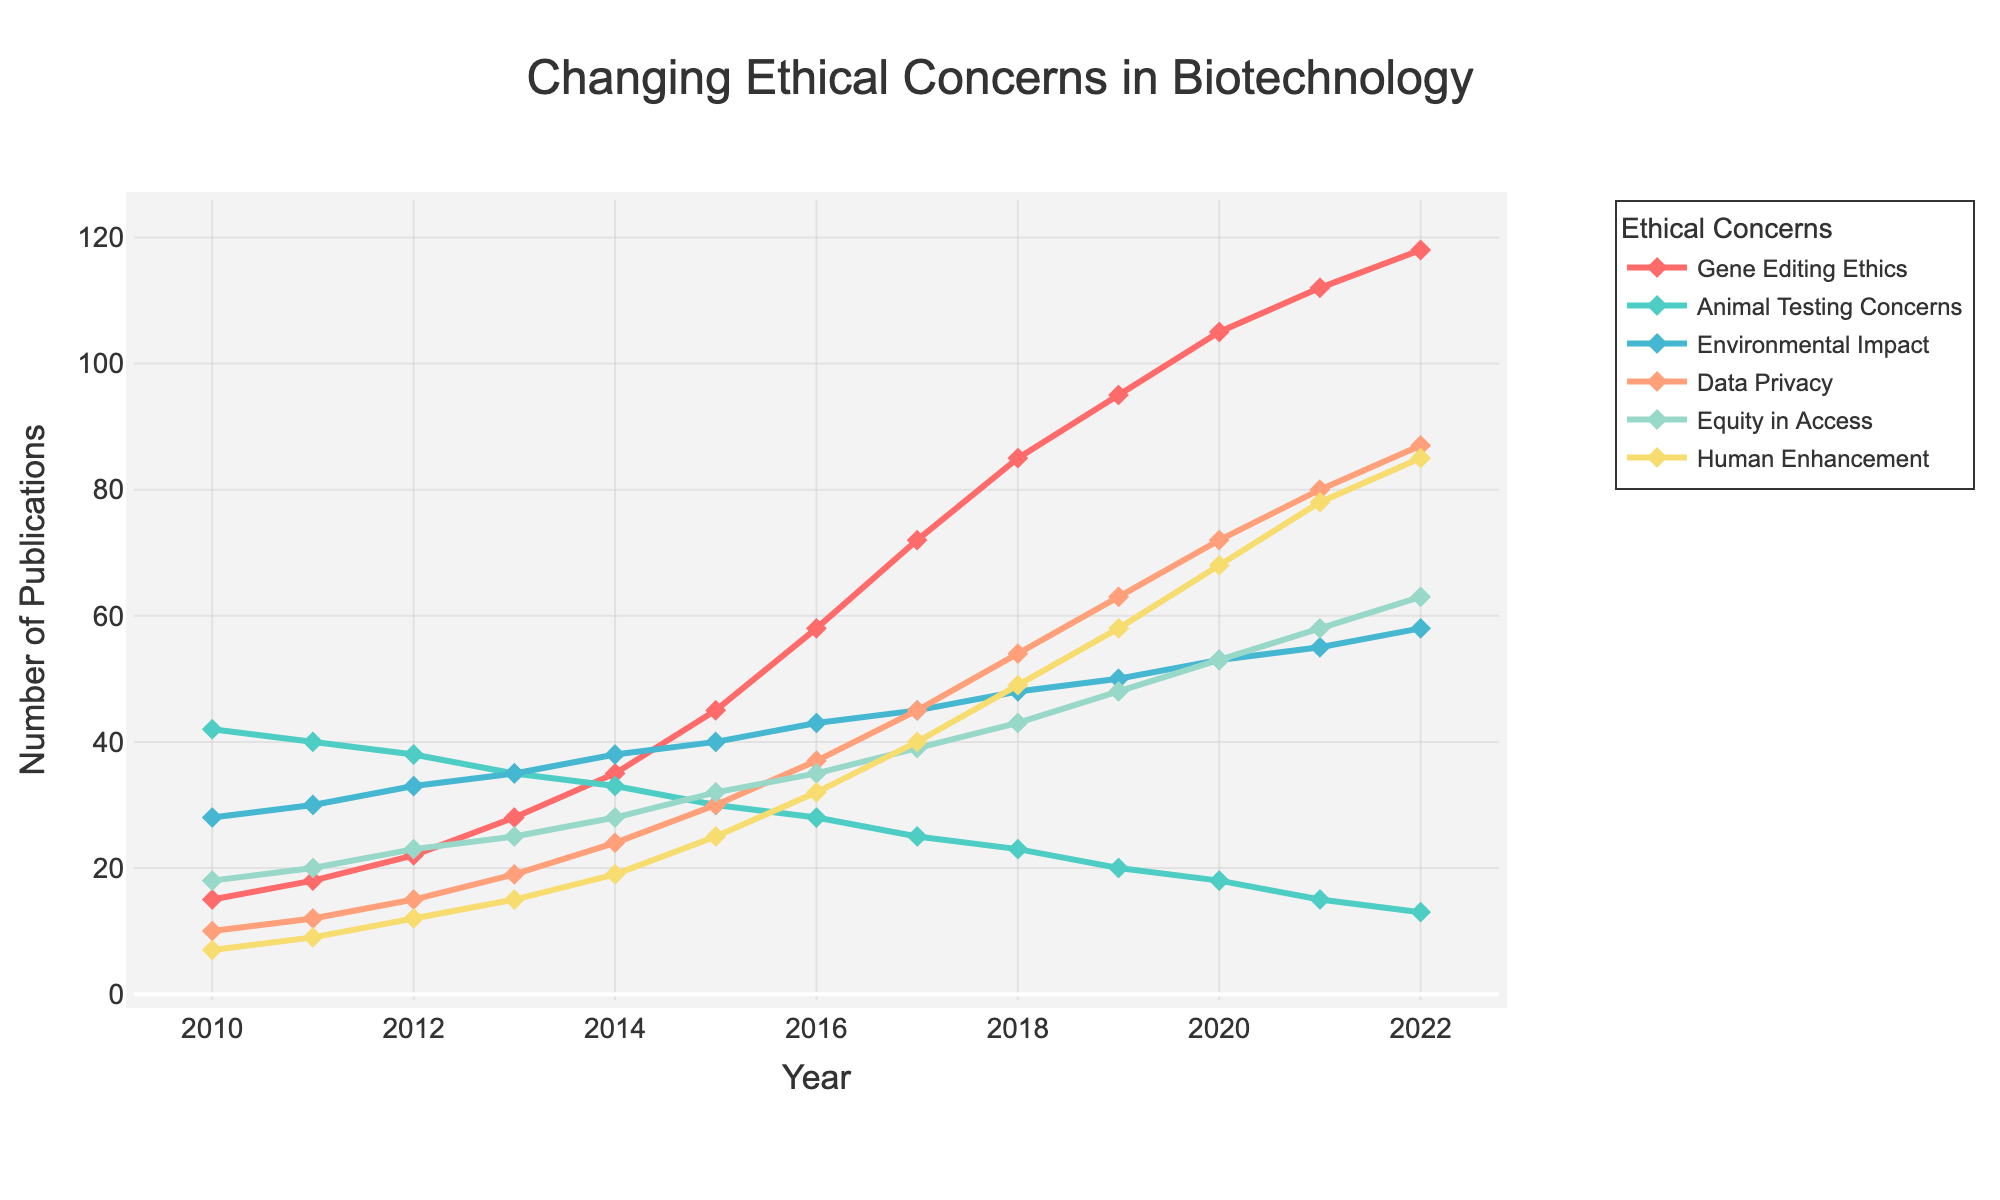Which ethical concern had the highest number of publications in 2022? To determine which ethical concern had the highest number of publications in 2022, look for the peak value in the data for the year 2022. "Gene Editing Ethics" has the highest value at 118 publications.
Answer: Gene Editing Ethics How has the trend for "Animal Testing Concerns" changed from 2010 to 2022? To understand the trend, look at the line representing "Animal Testing Concerns" and observe its direction from 2010 to 2022. The line shows a consistent decline in publications over this period.
Answer: Declined Which ethical concern saw the sharpest increase in publications between 2010 and 2022? Calculate the difference in publications for each concern between 2010 and 2022. The sharpest increase is for "Gene Editing Ethics," which increased from 15 to 118 publications, a difference of 103.
Answer: Gene Editing Ethics What is the difference between the number of publications on "Data Privacy" and "Environmental Impact" in 2020? Subtract the number of publications on "Environmental Impact" from the number on "Data Privacy" for 2020: 72 - 53 = 19.
Answer: 19 Which ethical concern switched from having fewer publications than "Equity in Access" in 2010 to having more publications in 2022? Compare the publications for "Equity in Access" and other concerns for 2010 and 2022. "Gene Editing Ethics" had fewer publications in 2010 (15 < 18) and more in 2022 (118 > 63).
Answer: Gene Editing Ethics What is the overall trend for the "Human Enhancement" publications from 2010 to 2022? Observe the line for "Human Enhancement" from 2010 to 2022. The line shows a continual upward trend, indicating an increase in publications.
Answer: Increased In which year did "Data Privacy" surpass "Animal Testing Concerns" in the number of publications? Trace the lines for "Data Privacy" and "Animal Testing Concerns" and find the year "Data Privacy" (in green) surpasses "Animal Testing Concerns" (in light blue). This occurs in 2013.
Answer: 2013 What was the publication difference for "Equity in Access" between 2015 and 2016? Subtract the number of publications for "Equity in Access" in 2015 from that in 2016: 35 - 32 = 3.
Answer: 3 Compare the publication trends of "Environmental Impact" and "Gene Editing Ethics" between 2010 and 2022. Observe the lines for "Environmental Impact" and "Gene Editing Ethics" from 2010 to 2022. "Environmental Impact" shows a gradual increase, while "Gene Editing Ethics" rises sharply.
Answer: "Environmental Impact" increased gradually; "Gene Editing Ethics" rose sharply Which ethical concern has the least variation in publication numbers from 2010 to 2022? Look at the spread of values for each ethical concern. "Animal Testing Concerns" has the least variation, starting at 42 and ending at 13, compared to other concerns with larger ranges.
Answer: Animal Testing Concerns 